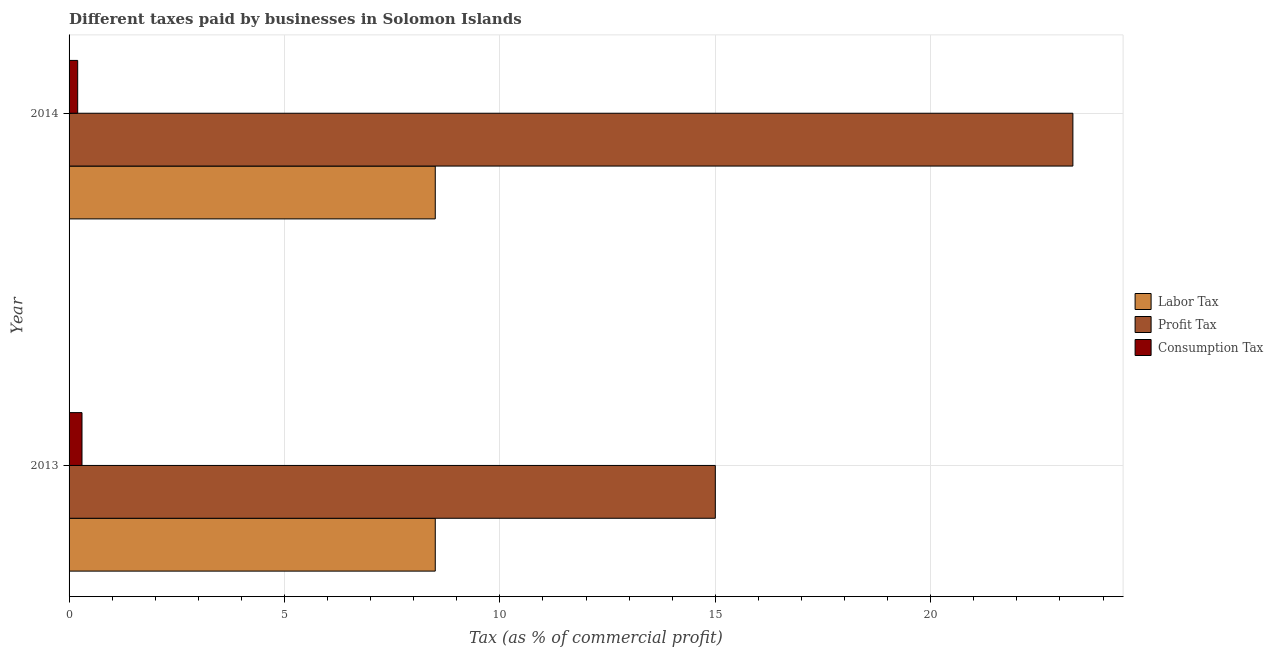What is the label of the 1st group of bars from the top?
Your response must be concise. 2014. Across all years, what is the minimum percentage of labor tax?
Make the answer very short. 8.5. In which year was the percentage of labor tax minimum?
Provide a succinct answer. 2013. What is the total percentage of consumption tax in the graph?
Give a very brief answer. 0.5. What is the difference between the percentage of consumption tax in 2013 and the percentage of profit tax in 2014?
Provide a succinct answer. -23. What is the average percentage of profit tax per year?
Offer a very short reply. 19.15. In the year 2014, what is the difference between the percentage of labor tax and percentage of profit tax?
Your answer should be compact. -14.8. In how many years, is the percentage of labor tax greater than 7 %?
Give a very brief answer. 2. What is the ratio of the percentage of labor tax in 2013 to that in 2014?
Your answer should be compact. 1. In how many years, is the percentage of profit tax greater than the average percentage of profit tax taken over all years?
Your response must be concise. 1. What does the 2nd bar from the top in 2013 represents?
Make the answer very short. Profit Tax. What does the 1st bar from the bottom in 2014 represents?
Make the answer very short. Labor Tax. Is it the case that in every year, the sum of the percentage of labor tax and percentage of profit tax is greater than the percentage of consumption tax?
Ensure brevity in your answer.  Yes. Are the values on the major ticks of X-axis written in scientific E-notation?
Provide a short and direct response. No. Does the graph contain any zero values?
Offer a very short reply. No. What is the title of the graph?
Keep it short and to the point. Different taxes paid by businesses in Solomon Islands. Does "Tertiary education" appear as one of the legend labels in the graph?
Keep it short and to the point. No. What is the label or title of the X-axis?
Your response must be concise. Tax (as % of commercial profit). What is the Tax (as % of commercial profit) of Profit Tax in 2013?
Your response must be concise. 15. What is the Tax (as % of commercial profit) of Consumption Tax in 2013?
Your response must be concise. 0.3. What is the Tax (as % of commercial profit) of Labor Tax in 2014?
Provide a short and direct response. 8.5. What is the Tax (as % of commercial profit) of Profit Tax in 2014?
Make the answer very short. 23.3. Across all years, what is the maximum Tax (as % of commercial profit) in Labor Tax?
Offer a very short reply. 8.5. Across all years, what is the maximum Tax (as % of commercial profit) in Profit Tax?
Your answer should be very brief. 23.3. Across all years, what is the minimum Tax (as % of commercial profit) in Labor Tax?
Offer a terse response. 8.5. Across all years, what is the minimum Tax (as % of commercial profit) in Consumption Tax?
Give a very brief answer. 0.2. What is the total Tax (as % of commercial profit) in Labor Tax in the graph?
Offer a terse response. 17. What is the total Tax (as % of commercial profit) of Profit Tax in the graph?
Your answer should be compact. 38.3. What is the difference between the Tax (as % of commercial profit) in Labor Tax in 2013 and that in 2014?
Your answer should be very brief. 0. What is the difference between the Tax (as % of commercial profit) in Profit Tax in 2013 and that in 2014?
Provide a succinct answer. -8.3. What is the difference between the Tax (as % of commercial profit) in Consumption Tax in 2013 and that in 2014?
Offer a terse response. 0.1. What is the difference between the Tax (as % of commercial profit) in Labor Tax in 2013 and the Tax (as % of commercial profit) in Profit Tax in 2014?
Keep it short and to the point. -14.8. What is the average Tax (as % of commercial profit) of Labor Tax per year?
Ensure brevity in your answer.  8.5. What is the average Tax (as % of commercial profit) in Profit Tax per year?
Your answer should be very brief. 19.15. What is the average Tax (as % of commercial profit) in Consumption Tax per year?
Your answer should be compact. 0.25. In the year 2013, what is the difference between the Tax (as % of commercial profit) in Labor Tax and Tax (as % of commercial profit) in Consumption Tax?
Give a very brief answer. 8.2. In the year 2014, what is the difference between the Tax (as % of commercial profit) in Labor Tax and Tax (as % of commercial profit) in Profit Tax?
Your answer should be very brief. -14.8. In the year 2014, what is the difference between the Tax (as % of commercial profit) in Labor Tax and Tax (as % of commercial profit) in Consumption Tax?
Keep it short and to the point. 8.3. In the year 2014, what is the difference between the Tax (as % of commercial profit) in Profit Tax and Tax (as % of commercial profit) in Consumption Tax?
Give a very brief answer. 23.1. What is the ratio of the Tax (as % of commercial profit) in Labor Tax in 2013 to that in 2014?
Ensure brevity in your answer.  1. What is the ratio of the Tax (as % of commercial profit) of Profit Tax in 2013 to that in 2014?
Your answer should be compact. 0.64. What is the ratio of the Tax (as % of commercial profit) in Consumption Tax in 2013 to that in 2014?
Offer a very short reply. 1.5. What is the difference between the highest and the second highest Tax (as % of commercial profit) in Labor Tax?
Offer a terse response. 0. What is the difference between the highest and the lowest Tax (as % of commercial profit) of Labor Tax?
Offer a terse response. 0. 